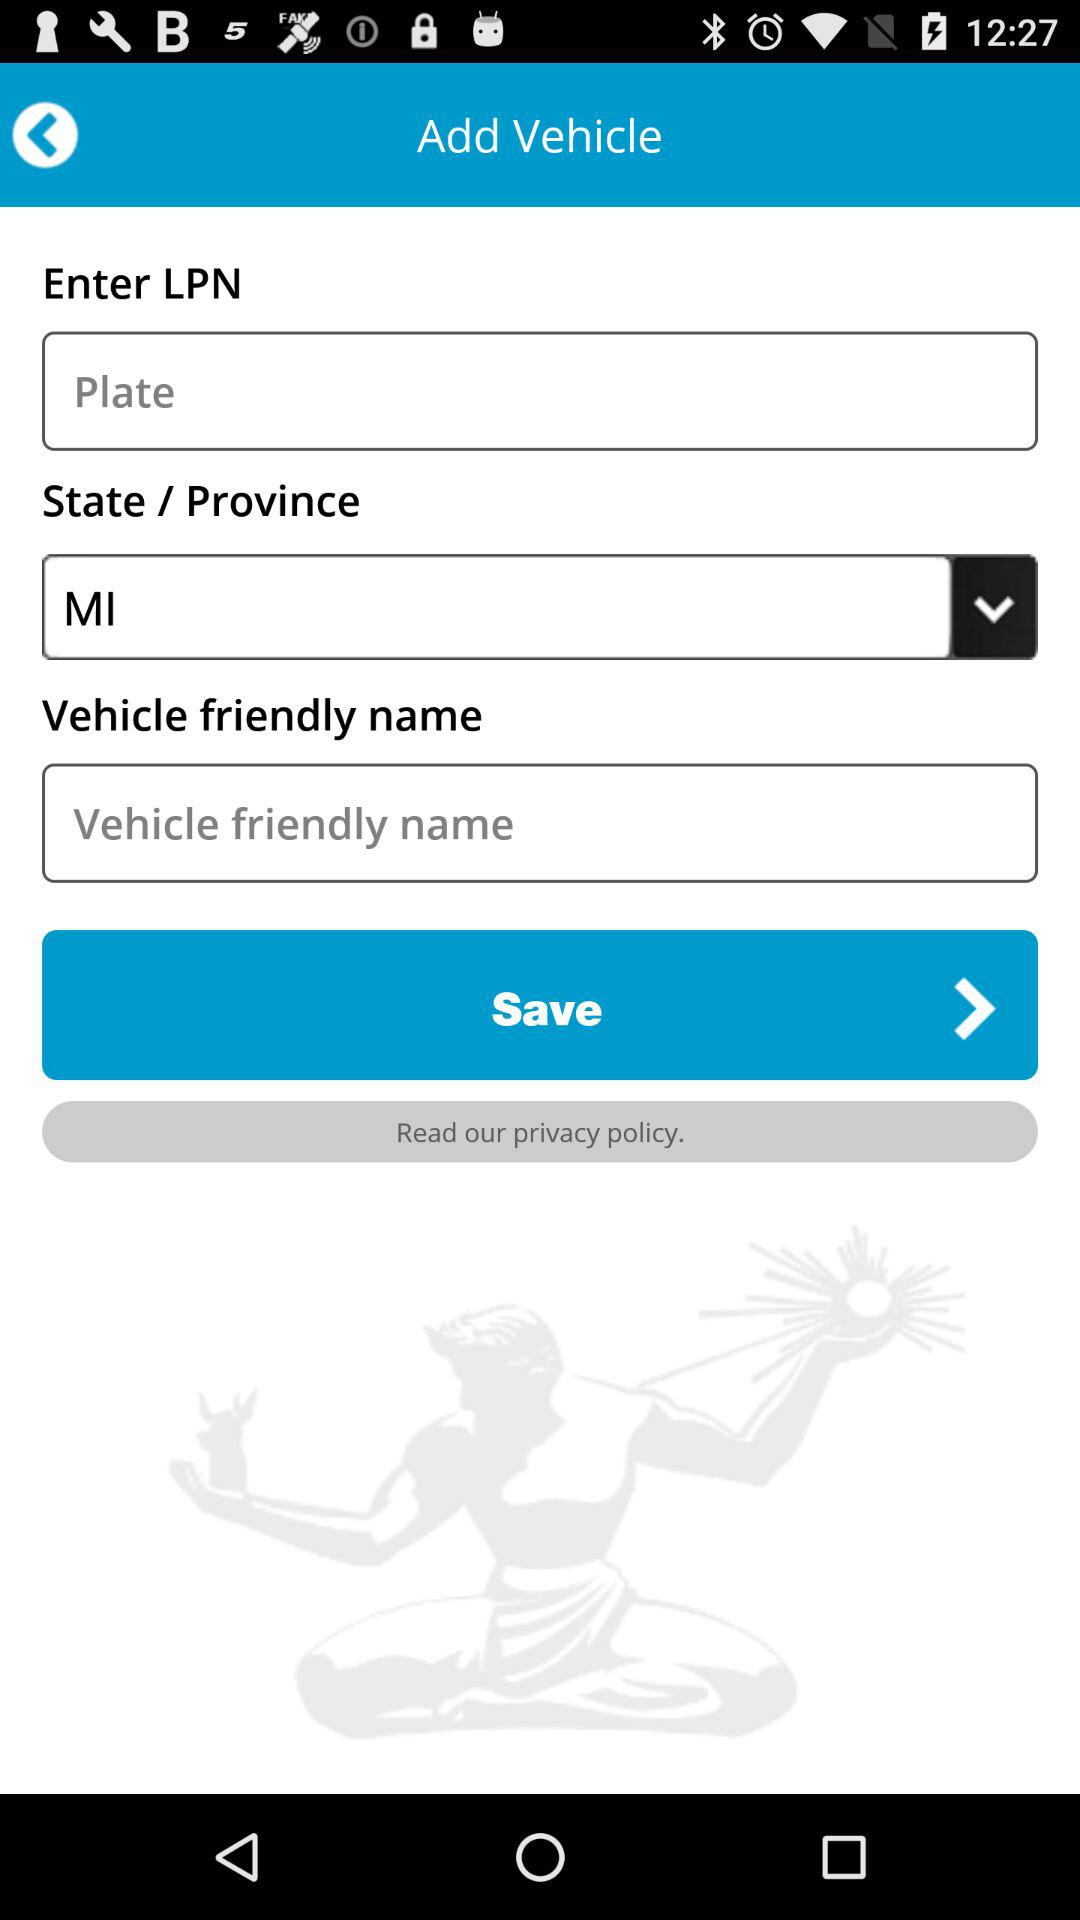Which state is selected? The selected state is MI. 